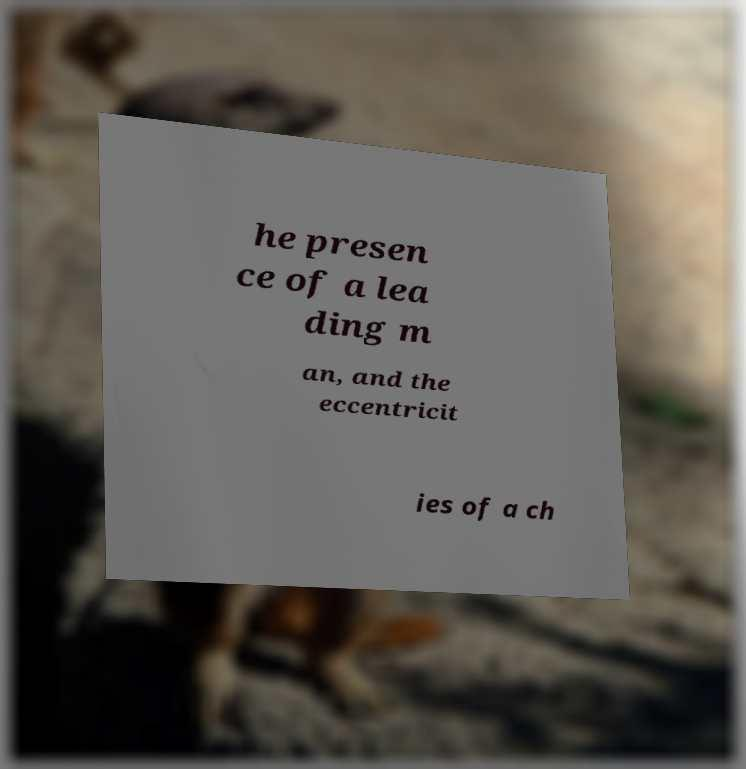Could you assist in decoding the text presented in this image and type it out clearly? he presen ce of a lea ding m an, and the eccentricit ies of a ch 